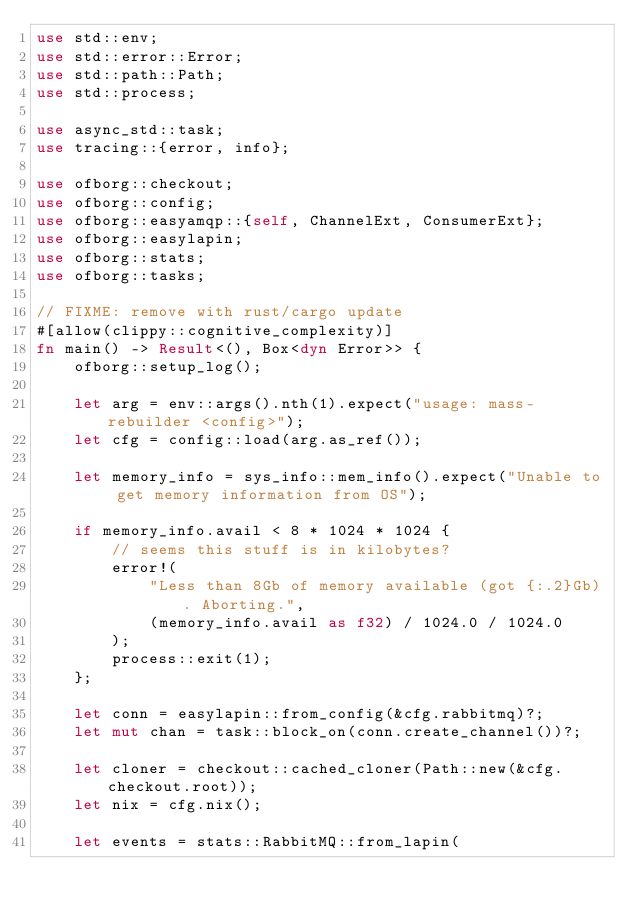<code> <loc_0><loc_0><loc_500><loc_500><_Rust_>use std::env;
use std::error::Error;
use std::path::Path;
use std::process;

use async_std::task;
use tracing::{error, info};

use ofborg::checkout;
use ofborg::config;
use ofborg::easyamqp::{self, ChannelExt, ConsumerExt};
use ofborg::easylapin;
use ofborg::stats;
use ofborg::tasks;

// FIXME: remove with rust/cargo update
#[allow(clippy::cognitive_complexity)]
fn main() -> Result<(), Box<dyn Error>> {
    ofborg::setup_log();

    let arg = env::args().nth(1).expect("usage: mass-rebuilder <config>");
    let cfg = config::load(arg.as_ref());

    let memory_info = sys_info::mem_info().expect("Unable to get memory information from OS");

    if memory_info.avail < 8 * 1024 * 1024 {
        // seems this stuff is in kilobytes?
        error!(
            "Less than 8Gb of memory available (got {:.2}Gb). Aborting.",
            (memory_info.avail as f32) / 1024.0 / 1024.0
        );
        process::exit(1);
    };

    let conn = easylapin::from_config(&cfg.rabbitmq)?;
    let mut chan = task::block_on(conn.create_channel())?;

    let cloner = checkout::cached_cloner(Path::new(&cfg.checkout.root));
    let nix = cfg.nix();

    let events = stats::RabbitMQ::from_lapin(</code> 